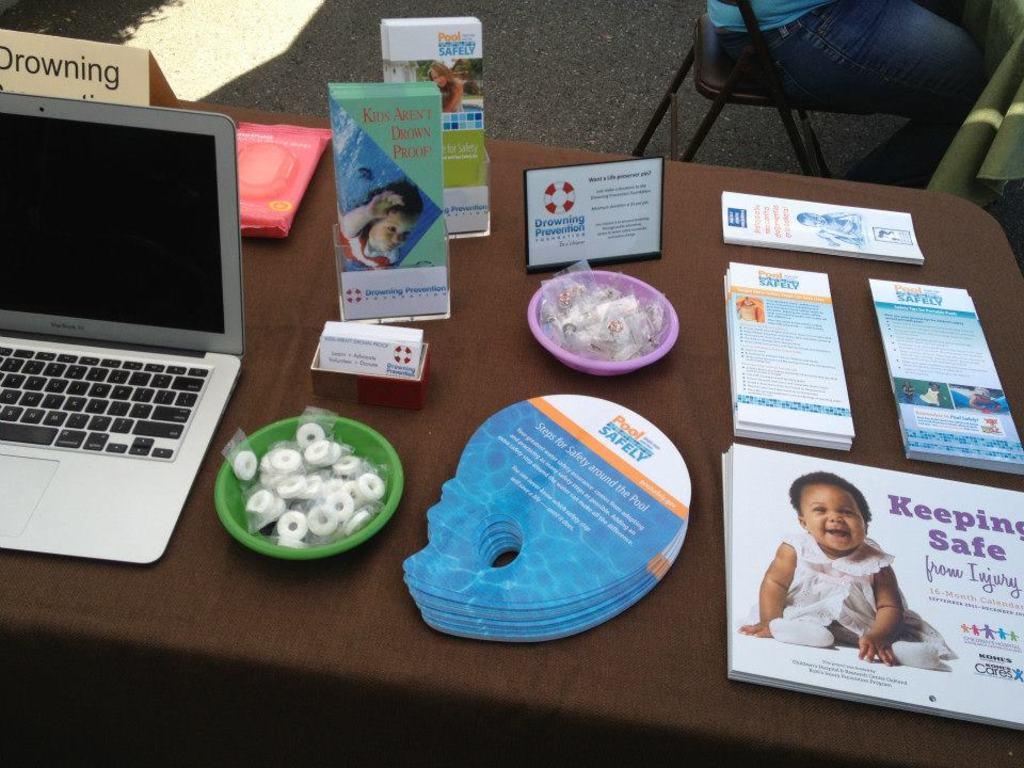What does the card with the baby say?
Offer a terse response. Keeping safe. What is the mostly blue pamphlet about?
Your response must be concise. Pool safety. 